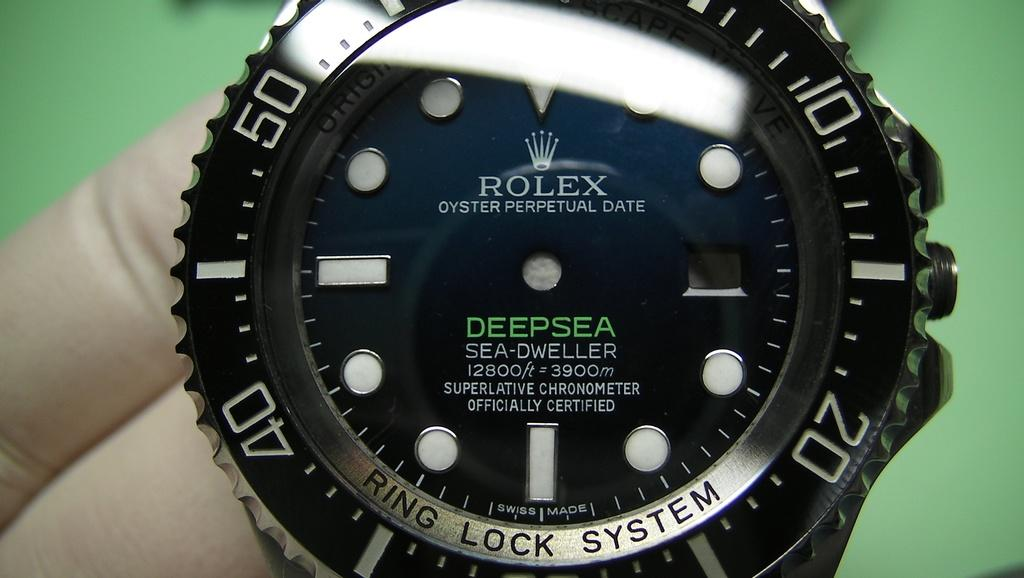<image>
Provide a brief description of the given image. A Rolex watch says it has oyster perpetual date. 